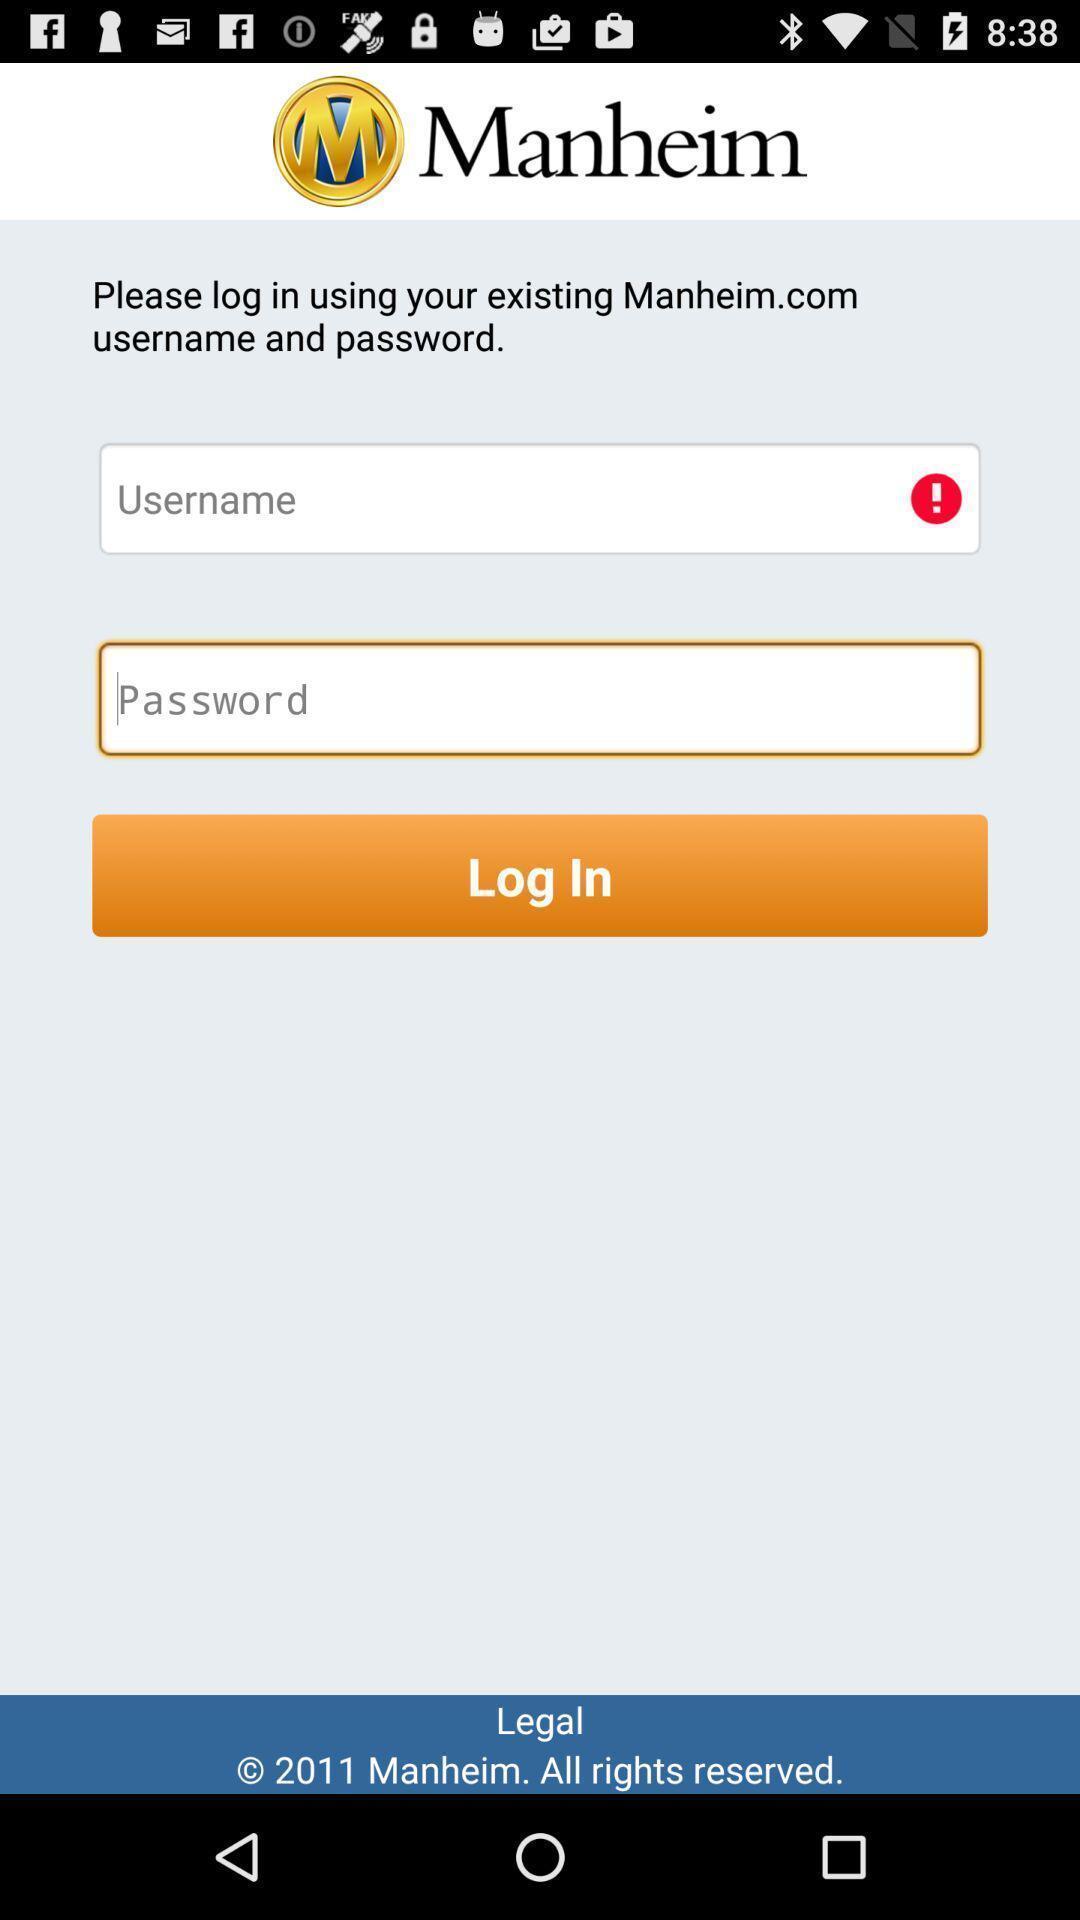Provide a detailed account of this screenshot. Screen displays the login page. 